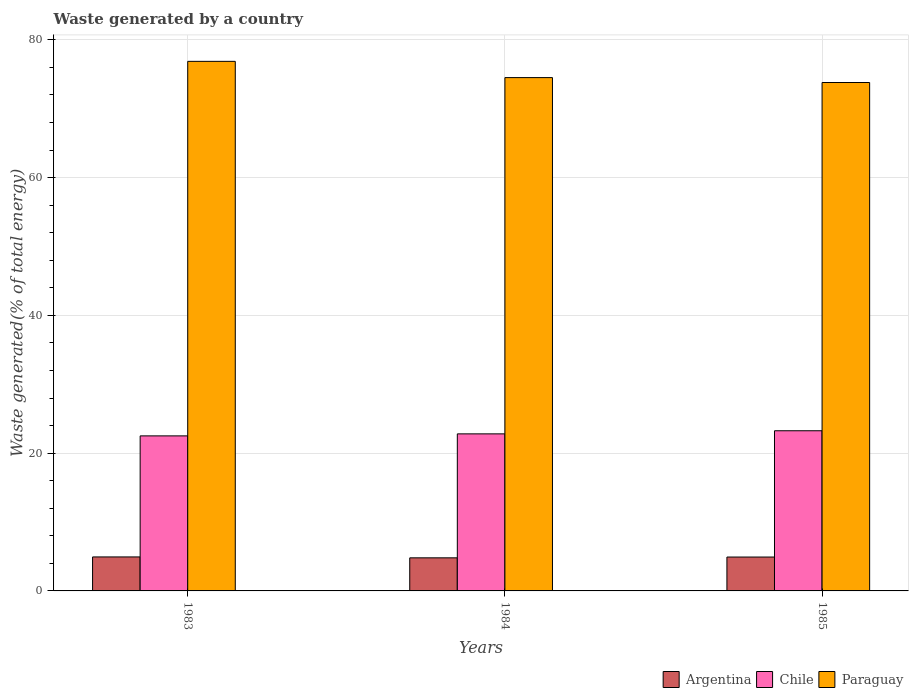Are the number of bars per tick equal to the number of legend labels?
Offer a terse response. Yes. What is the label of the 1st group of bars from the left?
Your answer should be compact. 1983. What is the total waste generated in Chile in 1985?
Offer a terse response. 23.25. Across all years, what is the maximum total waste generated in Paraguay?
Offer a terse response. 76.88. Across all years, what is the minimum total waste generated in Chile?
Your answer should be compact. 22.51. In which year was the total waste generated in Chile maximum?
Your response must be concise. 1985. What is the total total waste generated in Argentina in the graph?
Keep it short and to the point. 14.65. What is the difference between the total waste generated in Argentina in 1983 and that in 1985?
Provide a short and direct response. 0.02. What is the difference between the total waste generated in Paraguay in 1985 and the total waste generated in Chile in 1984?
Your response must be concise. 51.01. What is the average total waste generated in Argentina per year?
Your answer should be compact. 4.88. In the year 1983, what is the difference between the total waste generated in Chile and total waste generated in Paraguay?
Your answer should be compact. -54.37. What is the ratio of the total waste generated in Paraguay in 1983 to that in 1985?
Give a very brief answer. 1.04. Is the total waste generated in Paraguay in 1984 less than that in 1985?
Your response must be concise. No. Is the difference between the total waste generated in Chile in 1984 and 1985 greater than the difference between the total waste generated in Paraguay in 1984 and 1985?
Your response must be concise. No. What is the difference between the highest and the second highest total waste generated in Chile?
Keep it short and to the point. 0.45. What is the difference between the highest and the lowest total waste generated in Paraguay?
Your response must be concise. 3.07. In how many years, is the total waste generated in Chile greater than the average total waste generated in Chile taken over all years?
Your answer should be compact. 1. What does the 2nd bar from the left in 1985 represents?
Your answer should be compact. Chile. What does the 1st bar from the right in 1983 represents?
Keep it short and to the point. Paraguay. How many bars are there?
Offer a terse response. 9. What is the difference between two consecutive major ticks on the Y-axis?
Your answer should be compact. 20. Are the values on the major ticks of Y-axis written in scientific E-notation?
Ensure brevity in your answer.  No. Does the graph contain any zero values?
Your answer should be very brief. No. Does the graph contain grids?
Make the answer very short. Yes. How are the legend labels stacked?
Your answer should be very brief. Horizontal. What is the title of the graph?
Your response must be concise. Waste generated by a country. Does "Lithuania" appear as one of the legend labels in the graph?
Your answer should be very brief. No. What is the label or title of the X-axis?
Your answer should be compact. Years. What is the label or title of the Y-axis?
Your response must be concise. Waste generated(% of total energy). What is the Waste generated(% of total energy) of Argentina in 1983?
Your response must be concise. 4.93. What is the Waste generated(% of total energy) in Chile in 1983?
Your response must be concise. 22.51. What is the Waste generated(% of total energy) of Paraguay in 1983?
Offer a terse response. 76.88. What is the Waste generated(% of total energy) of Argentina in 1984?
Keep it short and to the point. 4.8. What is the Waste generated(% of total energy) in Chile in 1984?
Provide a succinct answer. 22.8. What is the Waste generated(% of total energy) of Paraguay in 1984?
Your answer should be compact. 74.52. What is the Waste generated(% of total energy) of Argentina in 1985?
Your answer should be very brief. 4.92. What is the Waste generated(% of total energy) in Chile in 1985?
Keep it short and to the point. 23.25. What is the Waste generated(% of total energy) in Paraguay in 1985?
Ensure brevity in your answer.  73.8. Across all years, what is the maximum Waste generated(% of total energy) of Argentina?
Your answer should be compact. 4.93. Across all years, what is the maximum Waste generated(% of total energy) in Chile?
Your response must be concise. 23.25. Across all years, what is the maximum Waste generated(% of total energy) of Paraguay?
Ensure brevity in your answer.  76.88. Across all years, what is the minimum Waste generated(% of total energy) of Argentina?
Your answer should be very brief. 4.8. Across all years, what is the minimum Waste generated(% of total energy) in Chile?
Your response must be concise. 22.51. Across all years, what is the minimum Waste generated(% of total energy) of Paraguay?
Provide a succinct answer. 73.8. What is the total Waste generated(% of total energy) in Argentina in the graph?
Provide a succinct answer. 14.65. What is the total Waste generated(% of total energy) of Chile in the graph?
Offer a terse response. 68.56. What is the total Waste generated(% of total energy) in Paraguay in the graph?
Your answer should be very brief. 225.2. What is the difference between the Waste generated(% of total energy) in Argentina in 1983 and that in 1984?
Your answer should be very brief. 0.13. What is the difference between the Waste generated(% of total energy) of Chile in 1983 and that in 1984?
Ensure brevity in your answer.  -0.29. What is the difference between the Waste generated(% of total energy) in Paraguay in 1983 and that in 1984?
Your answer should be very brief. 2.36. What is the difference between the Waste generated(% of total energy) in Argentina in 1983 and that in 1985?
Offer a terse response. 0.02. What is the difference between the Waste generated(% of total energy) in Chile in 1983 and that in 1985?
Provide a short and direct response. -0.74. What is the difference between the Waste generated(% of total energy) of Paraguay in 1983 and that in 1985?
Make the answer very short. 3.07. What is the difference between the Waste generated(% of total energy) of Argentina in 1984 and that in 1985?
Offer a very short reply. -0.11. What is the difference between the Waste generated(% of total energy) in Chile in 1984 and that in 1985?
Provide a short and direct response. -0.45. What is the difference between the Waste generated(% of total energy) of Paraguay in 1984 and that in 1985?
Provide a short and direct response. 0.71. What is the difference between the Waste generated(% of total energy) of Argentina in 1983 and the Waste generated(% of total energy) of Chile in 1984?
Your response must be concise. -17.87. What is the difference between the Waste generated(% of total energy) in Argentina in 1983 and the Waste generated(% of total energy) in Paraguay in 1984?
Offer a very short reply. -69.58. What is the difference between the Waste generated(% of total energy) in Chile in 1983 and the Waste generated(% of total energy) in Paraguay in 1984?
Offer a very short reply. -52.01. What is the difference between the Waste generated(% of total energy) in Argentina in 1983 and the Waste generated(% of total energy) in Chile in 1985?
Provide a succinct answer. -18.32. What is the difference between the Waste generated(% of total energy) in Argentina in 1983 and the Waste generated(% of total energy) in Paraguay in 1985?
Offer a terse response. -68.87. What is the difference between the Waste generated(% of total energy) in Chile in 1983 and the Waste generated(% of total energy) in Paraguay in 1985?
Make the answer very short. -51.3. What is the difference between the Waste generated(% of total energy) in Argentina in 1984 and the Waste generated(% of total energy) in Chile in 1985?
Your answer should be very brief. -18.45. What is the difference between the Waste generated(% of total energy) in Argentina in 1984 and the Waste generated(% of total energy) in Paraguay in 1985?
Offer a very short reply. -69. What is the difference between the Waste generated(% of total energy) in Chile in 1984 and the Waste generated(% of total energy) in Paraguay in 1985?
Make the answer very short. -51.01. What is the average Waste generated(% of total energy) in Argentina per year?
Your answer should be very brief. 4.88. What is the average Waste generated(% of total energy) of Chile per year?
Provide a short and direct response. 22.85. What is the average Waste generated(% of total energy) of Paraguay per year?
Your answer should be compact. 75.07. In the year 1983, what is the difference between the Waste generated(% of total energy) in Argentina and Waste generated(% of total energy) in Chile?
Make the answer very short. -17.57. In the year 1983, what is the difference between the Waste generated(% of total energy) in Argentina and Waste generated(% of total energy) in Paraguay?
Keep it short and to the point. -71.94. In the year 1983, what is the difference between the Waste generated(% of total energy) in Chile and Waste generated(% of total energy) in Paraguay?
Offer a very short reply. -54.37. In the year 1984, what is the difference between the Waste generated(% of total energy) of Argentina and Waste generated(% of total energy) of Chile?
Offer a terse response. -18. In the year 1984, what is the difference between the Waste generated(% of total energy) in Argentina and Waste generated(% of total energy) in Paraguay?
Provide a succinct answer. -69.71. In the year 1984, what is the difference between the Waste generated(% of total energy) in Chile and Waste generated(% of total energy) in Paraguay?
Keep it short and to the point. -51.72. In the year 1985, what is the difference between the Waste generated(% of total energy) in Argentina and Waste generated(% of total energy) in Chile?
Provide a short and direct response. -18.33. In the year 1985, what is the difference between the Waste generated(% of total energy) in Argentina and Waste generated(% of total energy) in Paraguay?
Offer a terse response. -68.89. In the year 1985, what is the difference between the Waste generated(% of total energy) in Chile and Waste generated(% of total energy) in Paraguay?
Offer a very short reply. -50.55. What is the ratio of the Waste generated(% of total energy) in Argentina in 1983 to that in 1984?
Make the answer very short. 1.03. What is the ratio of the Waste generated(% of total energy) of Chile in 1983 to that in 1984?
Offer a terse response. 0.99. What is the ratio of the Waste generated(% of total energy) in Paraguay in 1983 to that in 1984?
Your response must be concise. 1.03. What is the ratio of the Waste generated(% of total energy) in Argentina in 1983 to that in 1985?
Your response must be concise. 1. What is the ratio of the Waste generated(% of total energy) of Paraguay in 1983 to that in 1985?
Your answer should be compact. 1.04. What is the ratio of the Waste generated(% of total energy) in Argentina in 1984 to that in 1985?
Make the answer very short. 0.98. What is the ratio of the Waste generated(% of total energy) of Chile in 1984 to that in 1985?
Make the answer very short. 0.98. What is the ratio of the Waste generated(% of total energy) of Paraguay in 1984 to that in 1985?
Keep it short and to the point. 1.01. What is the difference between the highest and the second highest Waste generated(% of total energy) in Argentina?
Keep it short and to the point. 0.02. What is the difference between the highest and the second highest Waste generated(% of total energy) of Chile?
Make the answer very short. 0.45. What is the difference between the highest and the second highest Waste generated(% of total energy) in Paraguay?
Your answer should be very brief. 2.36. What is the difference between the highest and the lowest Waste generated(% of total energy) of Argentina?
Provide a succinct answer. 0.13. What is the difference between the highest and the lowest Waste generated(% of total energy) in Chile?
Offer a very short reply. 0.74. What is the difference between the highest and the lowest Waste generated(% of total energy) of Paraguay?
Give a very brief answer. 3.07. 